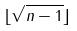<formula> <loc_0><loc_0><loc_500><loc_500>\lfloor \sqrt { n - 1 } \rfloor</formula> 